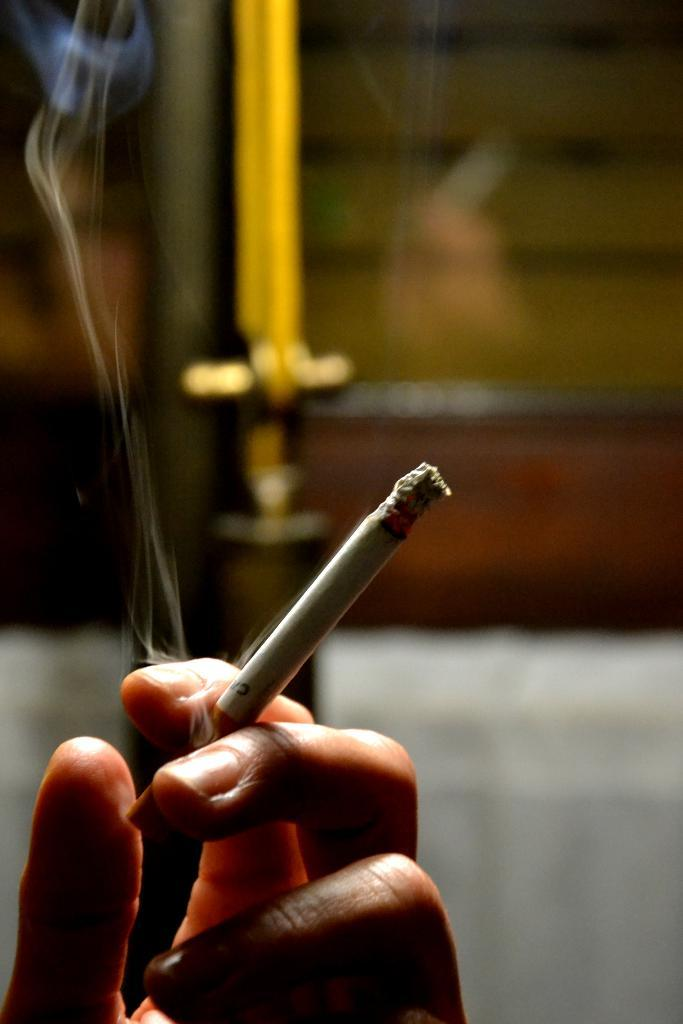What is the main subject of the image? There is a person in the image. What is the person holding in the image? The person is holding a cigarette. Can you describe the background of the image? The background of the image is blurred. Where is the pin located in the image? There is no pin present in the image. What type of faucet can be seen in the image? There is no faucet present in the image. 